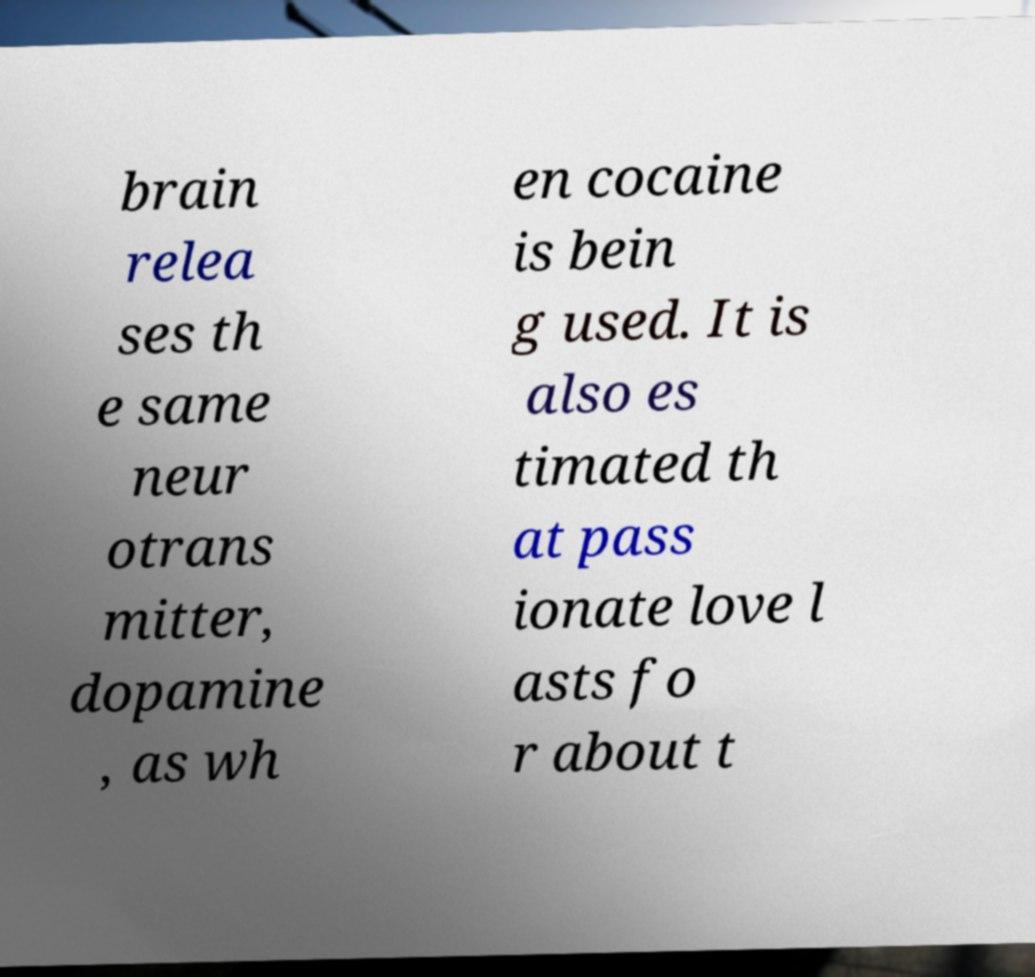Could you assist in decoding the text presented in this image and type it out clearly? brain relea ses th e same neur otrans mitter, dopamine , as wh en cocaine is bein g used. It is also es timated th at pass ionate love l asts fo r about t 